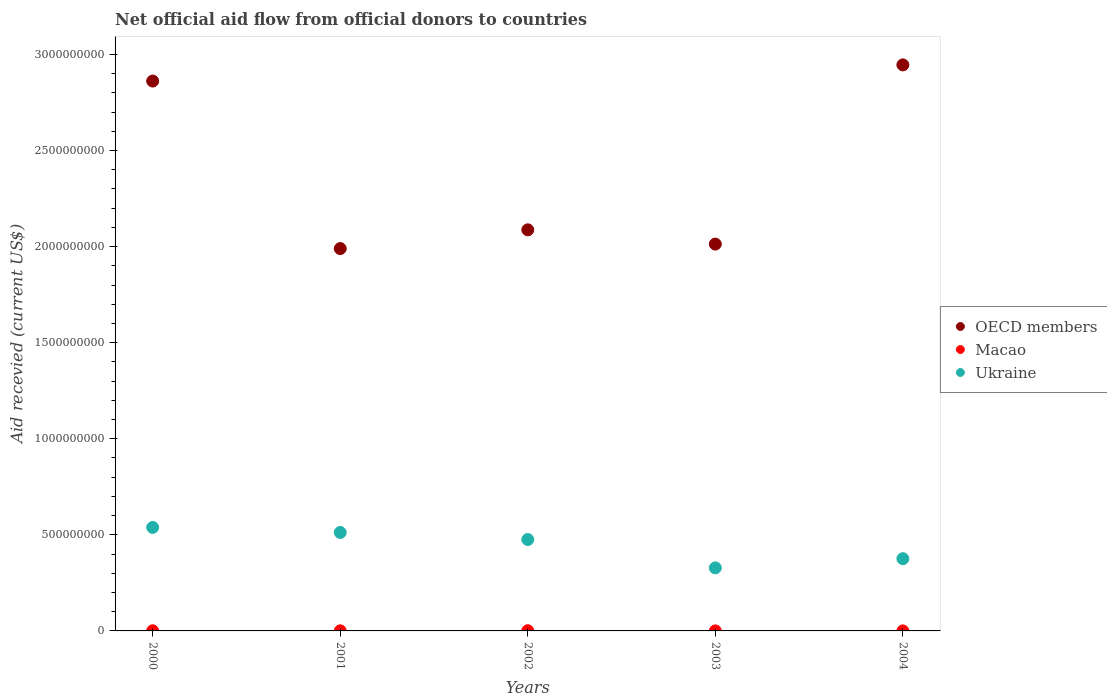Is the number of dotlines equal to the number of legend labels?
Your answer should be compact. Yes. What is the total aid received in OECD members in 2003?
Provide a short and direct response. 2.01e+09. Across all years, what is the maximum total aid received in OECD members?
Give a very brief answer. 2.95e+09. Across all years, what is the minimum total aid received in OECD members?
Offer a very short reply. 1.99e+09. In which year was the total aid received in Ukraine minimum?
Your answer should be very brief. 2003. What is the total total aid received in Macao in the graph?
Make the answer very short. 2.44e+06. What is the difference between the total aid received in OECD members in 2000 and that in 2002?
Ensure brevity in your answer.  7.74e+08. What is the difference between the total aid received in Ukraine in 2003 and the total aid received in OECD members in 2001?
Your answer should be very brief. -1.66e+09. What is the average total aid received in Macao per year?
Your response must be concise. 4.88e+05. In the year 2000, what is the difference between the total aid received in Macao and total aid received in Ukraine?
Provide a succinct answer. -5.38e+08. What is the ratio of the total aid received in Macao in 2001 to that in 2003?
Ensure brevity in your answer.  4.08. Is the total aid received in OECD members in 2000 less than that in 2004?
Offer a terse response. Yes. What is the difference between the highest and the second highest total aid received in Macao?
Your answer should be compact. 3.00e+05. What is the difference between the highest and the lowest total aid received in Ukraine?
Keep it short and to the point. 2.10e+08. Does the total aid received in OECD members monotonically increase over the years?
Your response must be concise. No. Is the total aid received in OECD members strictly less than the total aid received in Macao over the years?
Offer a very short reply. No. How many dotlines are there?
Offer a very short reply. 3. What is the difference between two consecutive major ticks on the Y-axis?
Your response must be concise. 5.00e+08. Are the values on the major ticks of Y-axis written in scientific E-notation?
Provide a short and direct response. No. Where does the legend appear in the graph?
Offer a very short reply. Center right. How are the legend labels stacked?
Offer a very short reply. Vertical. What is the title of the graph?
Provide a short and direct response. Net official aid flow from official donors to countries. What is the label or title of the X-axis?
Your response must be concise. Years. What is the label or title of the Y-axis?
Ensure brevity in your answer.  Aid recevied (current US$). What is the Aid recevied (current US$) in OECD members in 2000?
Provide a succinct answer. 2.86e+09. What is the Aid recevied (current US$) of Macao in 2000?
Give a very brief answer. 6.80e+05. What is the Aid recevied (current US$) in Ukraine in 2000?
Offer a very short reply. 5.39e+08. What is the Aid recevied (current US$) in OECD members in 2001?
Offer a very short reply. 1.99e+09. What is the Aid recevied (current US$) of Macao in 2001?
Your response must be concise. 5.30e+05. What is the Aid recevied (current US$) of Ukraine in 2001?
Offer a very short reply. 5.12e+08. What is the Aid recevied (current US$) in OECD members in 2002?
Provide a short and direct response. 2.09e+09. What is the Aid recevied (current US$) of Macao in 2002?
Your response must be concise. 9.80e+05. What is the Aid recevied (current US$) of Ukraine in 2002?
Your response must be concise. 4.76e+08. What is the Aid recevied (current US$) of OECD members in 2003?
Your answer should be very brief. 2.01e+09. What is the Aid recevied (current US$) in Macao in 2003?
Ensure brevity in your answer.  1.30e+05. What is the Aid recevied (current US$) in Ukraine in 2003?
Your response must be concise. 3.28e+08. What is the Aid recevied (current US$) of OECD members in 2004?
Provide a succinct answer. 2.95e+09. What is the Aid recevied (current US$) of Macao in 2004?
Provide a short and direct response. 1.20e+05. What is the Aid recevied (current US$) of Ukraine in 2004?
Your answer should be very brief. 3.76e+08. Across all years, what is the maximum Aid recevied (current US$) in OECD members?
Provide a short and direct response. 2.95e+09. Across all years, what is the maximum Aid recevied (current US$) in Macao?
Make the answer very short. 9.80e+05. Across all years, what is the maximum Aid recevied (current US$) in Ukraine?
Your answer should be compact. 5.39e+08. Across all years, what is the minimum Aid recevied (current US$) of OECD members?
Provide a succinct answer. 1.99e+09. Across all years, what is the minimum Aid recevied (current US$) of Ukraine?
Ensure brevity in your answer.  3.28e+08. What is the total Aid recevied (current US$) in OECD members in the graph?
Give a very brief answer. 1.19e+1. What is the total Aid recevied (current US$) of Macao in the graph?
Make the answer very short. 2.44e+06. What is the total Aid recevied (current US$) of Ukraine in the graph?
Make the answer very short. 2.23e+09. What is the difference between the Aid recevied (current US$) in OECD members in 2000 and that in 2001?
Offer a very short reply. 8.72e+08. What is the difference between the Aid recevied (current US$) of Ukraine in 2000 and that in 2001?
Ensure brevity in your answer.  2.62e+07. What is the difference between the Aid recevied (current US$) in OECD members in 2000 and that in 2002?
Provide a short and direct response. 7.74e+08. What is the difference between the Aid recevied (current US$) in Ukraine in 2000 and that in 2002?
Your answer should be very brief. 6.32e+07. What is the difference between the Aid recevied (current US$) in OECD members in 2000 and that in 2003?
Offer a very short reply. 8.48e+08. What is the difference between the Aid recevied (current US$) of Ukraine in 2000 and that in 2003?
Give a very brief answer. 2.10e+08. What is the difference between the Aid recevied (current US$) of OECD members in 2000 and that in 2004?
Your answer should be very brief. -8.42e+07. What is the difference between the Aid recevied (current US$) in Macao in 2000 and that in 2004?
Offer a very short reply. 5.60e+05. What is the difference between the Aid recevied (current US$) in Ukraine in 2000 and that in 2004?
Give a very brief answer. 1.63e+08. What is the difference between the Aid recevied (current US$) in OECD members in 2001 and that in 2002?
Provide a short and direct response. -9.76e+07. What is the difference between the Aid recevied (current US$) of Macao in 2001 and that in 2002?
Your answer should be very brief. -4.50e+05. What is the difference between the Aid recevied (current US$) of Ukraine in 2001 and that in 2002?
Make the answer very short. 3.69e+07. What is the difference between the Aid recevied (current US$) of OECD members in 2001 and that in 2003?
Provide a succinct answer. -2.34e+07. What is the difference between the Aid recevied (current US$) in Ukraine in 2001 and that in 2003?
Offer a terse response. 1.84e+08. What is the difference between the Aid recevied (current US$) of OECD members in 2001 and that in 2004?
Your response must be concise. -9.56e+08. What is the difference between the Aid recevied (current US$) of Ukraine in 2001 and that in 2004?
Your response must be concise. 1.36e+08. What is the difference between the Aid recevied (current US$) of OECD members in 2002 and that in 2003?
Your answer should be compact. 7.41e+07. What is the difference between the Aid recevied (current US$) in Macao in 2002 and that in 2003?
Ensure brevity in your answer.  8.50e+05. What is the difference between the Aid recevied (current US$) of Ukraine in 2002 and that in 2003?
Your answer should be very brief. 1.47e+08. What is the difference between the Aid recevied (current US$) in OECD members in 2002 and that in 2004?
Offer a very short reply. -8.58e+08. What is the difference between the Aid recevied (current US$) in Macao in 2002 and that in 2004?
Provide a succinct answer. 8.60e+05. What is the difference between the Aid recevied (current US$) of Ukraine in 2002 and that in 2004?
Provide a short and direct response. 9.96e+07. What is the difference between the Aid recevied (current US$) in OECD members in 2003 and that in 2004?
Make the answer very short. -9.33e+08. What is the difference between the Aid recevied (current US$) of Macao in 2003 and that in 2004?
Give a very brief answer. 10000. What is the difference between the Aid recevied (current US$) of Ukraine in 2003 and that in 2004?
Your answer should be very brief. -4.78e+07. What is the difference between the Aid recevied (current US$) in OECD members in 2000 and the Aid recevied (current US$) in Macao in 2001?
Make the answer very short. 2.86e+09. What is the difference between the Aid recevied (current US$) of OECD members in 2000 and the Aid recevied (current US$) of Ukraine in 2001?
Provide a succinct answer. 2.35e+09. What is the difference between the Aid recevied (current US$) in Macao in 2000 and the Aid recevied (current US$) in Ukraine in 2001?
Make the answer very short. -5.12e+08. What is the difference between the Aid recevied (current US$) in OECD members in 2000 and the Aid recevied (current US$) in Macao in 2002?
Provide a succinct answer. 2.86e+09. What is the difference between the Aid recevied (current US$) in OECD members in 2000 and the Aid recevied (current US$) in Ukraine in 2002?
Your response must be concise. 2.39e+09. What is the difference between the Aid recevied (current US$) of Macao in 2000 and the Aid recevied (current US$) of Ukraine in 2002?
Your response must be concise. -4.75e+08. What is the difference between the Aid recevied (current US$) of OECD members in 2000 and the Aid recevied (current US$) of Macao in 2003?
Provide a short and direct response. 2.86e+09. What is the difference between the Aid recevied (current US$) in OECD members in 2000 and the Aid recevied (current US$) in Ukraine in 2003?
Ensure brevity in your answer.  2.53e+09. What is the difference between the Aid recevied (current US$) of Macao in 2000 and the Aid recevied (current US$) of Ukraine in 2003?
Make the answer very short. -3.28e+08. What is the difference between the Aid recevied (current US$) in OECD members in 2000 and the Aid recevied (current US$) in Macao in 2004?
Provide a short and direct response. 2.86e+09. What is the difference between the Aid recevied (current US$) in OECD members in 2000 and the Aid recevied (current US$) in Ukraine in 2004?
Ensure brevity in your answer.  2.49e+09. What is the difference between the Aid recevied (current US$) of Macao in 2000 and the Aid recevied (current US$) of Ukraine in 2004?
Your answer should be compact. -3.75e+08. What is the difference between the Aid recevied (current US$) in OECD members in 2001 and the Aid recevied (current US$) in Macao in 2002?
Your answer should be very brief. 1.99e+09. What is the difference between the Aid recevied (current US$) of OECD members in 2001 and the Aid recevied (current US$) of Ukraine in 2002?
Offer a very short reply. 1.51e+09. What is the difference between the Aid recevied (current US$) in Macao in 2001 and the Aid recevied (current US$) in Ukraine in 2002?
Offer a terse response. -4.75e+08. What is the difference between the Aid recevied (current US$) of OECD members in 2001 and the Aid recevied (current US$) of Macao in 2003?
Make the answer very short. 1.99e+09. What is the difference between the Aid recevied (current US$) in OECD members in 2001 and the Aid recevied (current US$) in Ukraine in 2003?
Make the answer very short. 1.66e+09. What is the difference between the Aid recevied (current US$) in Macao in 2001 and the Aid recevied (current US$) in Ukraine in 2003?
Provide a succinct answer. -3.28e+08. What is the difference between the Aid recevied (current US$) of OECD members in 2001 and the Aid recevied (current US$) of Macao in 2004?
Provide a short and direct response. 1.99e+09. What is the difference between the Aid recevied (current US$) in OECD members in 2001 and the Aid recevied (current US$) in Ukraine in 2004?
Your answer should be very brief. 1.61e+09. What is the difference between the Aid recevied (current US$) in Macao in 2001 and the Aid recevied (current US$) in Ukraine in 2004?
Ensure brevity in your answer.  -3.75e+08. What is the difference between the Aid recevied (current US$) in OECD members in 2002 and the Aid recevied (current US$) in Macao in 2003?
Your answer should be compact. 2.09e+09. What is the difference between the Aid recevied (current US$) in OECD members in 2002 and the Aid recevied (current US$) in Ukraine in 2003?
Your answer should be very brief. 1.76e+09. What is the difference between the Aid recevied (current US$) in Macao in 2002 and the Aid recevied (current US$) in Ukraine in 2003?
Offer a very short reply. -3.27e+08. What is the difference between the Aid recevied (current US$) of OECD members in 2002 and the Aid recevied (current US$) of Macao in 2004?
Give a very brief answer. 2.09e+09. What is the difference between the Aid recevied (current US$) of OECD members in 2002 and the Aid recevied (current US$) of Ukraine in 2004?
Ensure brevity in your answer.  1.71e+09. What is the difference between the Aid recevied (current US$) in Macao in 2002 and the Aid recevied (current US$) in Ukraine in 2004?
Ensure brevity in your answer.  -3.75e+08. What is the difference between the Aid recevied (current US$) of OECD members in 2003 and the Aid recevied (current US$) of Macao in 2004?
Give a very brief answer. 2.01e+09. What is the difference between the Aid recevied (current US$) of OECD members in 2003 and the Aid recevied (current US$) of Ukraine in 2004?
Your answer should be very brief. 1.64e+09. What is the difference between the Aid recevied (current US$) in Macao in 2003 and the Aid recevied (current US$) in Ukraine in 2004?
Your answer should be very brief. -3.76e+08. What is the average Aid recevied (current US$) in OECD members per year?
Make the answer very short. 2.38e+09. What is the average Aid recevied (current US$) in Macao per year?
Provide a succinct answer. 4.88e+05. What is the average Aid recevied (current US$) of Ukraine per year?
Provide a succinct answer. 4.46e+08. In the year 2000, what is the difference between the Aid recevied (current US$) of OECD members and Aid recevied (current US$) of Macao?
Ensure brevity in your answer.  2.86e+09. In the year 2000, what is the difference between the Aid recevied (current US$) of OECD members and Aid recevied (current US$) of Ukraine?
Offer a very short reply. 2.32e+09. In the year 2000, what is the difference between the Aid recevied (current US$) of Macao and Aid recevied (current US$) of Ukraine?
Your answer should be very brief. -5.38e+08. In the year 2001, what is the difference between the Aid recevied (current US$) of OECD members and Aid recevied (current US$) of Macao?
Provide a short and direct response. 1.99e+09. In the year 2001, what is the difference between the Aid recevied (current US$) in OECD members and Aid recevied (current US$) in Ukraine?
Ensure brevity in your answer.  1.48e+09. In the year 2001, what is the difference between the Aid recevied (current US$) of Macao and Aid recevied (current US$) of Ukraine?
Your response must be concise. -5.12e+08. In the year 2002, what is the difference between the Aid recevied (current US$) of OECD members and Aid recevied (current US$) of Macao?
Provide a short and direct response. 2.09e+09. In the year 2002, what is the difference between the Aid recevied (current US$) in OECD members and Aid recevied (current US$) in Ukraine?
Your response must be concise. 1.61e+09. In the year 2002, what is the difference between the Aid recevied (current US$) in Macao and Aid recevied (current US$) in Ukraine?
Your answer should be very brief. -4.75e+08. In the year 2003, what is the difference between the Aid recevied (current US$) of OECD members and Aid recevied (current US$) of Macao?
Offer a terse response. 2.01e+09. In the year 2003, what is the difference between the Aid recevied (current US$) in OECD members and Aid recevied (current US$) in Ukraine?
Your response must be concise. 1.68e+09. In the year 2003, what is the difference between the Aid recevied (current US$) in Macao and Aid recevied (current US$) in Ukraine?
Give a very brief answer. -3.28e+08. In the year 2004, what is the difference between the Aid recevied (current US$) of OECD members and Aid recevied (current US$) of Macao?
Give a very brief answer. 2.95e+09. In the year 2004, what is the difference between the Aid recevied (current US$) in OECD members and Aid recevied (current US$) in Ukraine?
Your answer should be very brief. 2.57e+09. In the year 2004, what is the difference between the Aid recevied (current US$) in Macao and Aid recevied (current US$) in Ukraine?
Offer a terse response. -3.76e+08. What is the ratio of the Aid recevied (current US$) of OECD members in 2000 to that in 2001?
Ensure brevity in your answer.  1.44. What is the ratio of the Aid recevied (current US$) in Macao in 2000 to that in 2001?
Provide a short and direct response. 1.28. What is the ratio of the Aid recevied (current US$) in Ukraine in 2000 to that in 2001?
Provide a short and direct response. 1.05. What is the ratio of the Aid recevied (current US$) in OECD members in 2000 to that in 2002?
Make the answer very short. 1.37. What is the ratio of the Aid recevied (current US$) of Macao in 2000 to that in 2002?
Offer a very short reply. 0.69. What is the ratio of the Aid recevied (current US$) in Ukraine in 2000 to that in 2002?
Give a very brief answer. 1.13. What is the ratio of the Aid recevied (current US$) of OECD members in 2000 to that in 2003?
Offer a very short reply. 1.42. What is the ratio of the Aid recevied (current US$) of Macao in 2000 to that in 2003?
Ensure brevity in your answer.  5.23. What is the ratio of the Aid recevied (current US$) of Ukraine in 2000 to that in 2003?
Keep it short and to the point. 1.64. What is the ratio of the Aid recevied (current US$) in OECD members in 2000 to that in 2004?
Your response must be concise. 0.97. What is the ratio of the Aid recevied (current US$) of Macao in 2000 to that in 2004?
Provide a short and direct response. 5.67. What is the ratio of the Aid recevied (current US$) of Ukraine in 2000 to that in 2004?
Keep it short and to the point. 1.43. What is the ratio of the Aid recevied (current US$) in OECD members in 2001 to that in 2002?
Make the answer very short. 0.95. What is the ratio of the Aid recevied (current US$) in Macao in 2001 to that in 2002?
Your answer should be very brief. 0.54. What is the ratio of the Aid recevied (current US$) in Ukraine in 2001 to that in 2002?
Keep it short and to the point. 1.08. What is the ratio of the Aid recevied (current US$) in OECD members in 2001 to that in 2003?
Make the answer very short. 0.99. What is the ratio of the Aid recevied (current US$) of Macao in 2001 to that in 2003?
Ensure brevity in your answer.  4.08. What is the ratio of the Aid recevied (current US$) in Ukraine in 2001 to that in 2003?
Your response must be concise. 1.56. What is the ratio of the Aid recevied (current US$) of OECD members in 2001 to that in 2004?
Offer a terse response. 0.68. What is the ratio of the Aid recevied (current US$) of Macao in 2001 to that in 2004?
Offer a terse response. 4.42. What is the ratio of the Aid recevied (current US$) of Ukraine in 2001 to that in 2004?
Your answer should be compact. 1.36. What is the ratio of the Aid recevied (current US$) in OECD members in 2002 to that in 2003?
Your answer should be compact. 1.04. What is the ratio of the Aid recevied (current US$) in Macao in 2002 to that in 2003?
Provide a succinct answer. 7.54. What is the ratio of the Aid recevied (current US$) in Ukraine in 2002 to that in 2003?
Your answer should be compact. 1.45. What is the ratio of the Aid recevied (current US$) in OECD members in 2002 to that in 2004?
Your answer should be very brief. 0.71. What is the ratio of the Aid recevied (current US$) of Macao in 2002 to that in 2004?
Give a very brief answer. 8.17. What is the ratio of the Aid recevied (current US$) in Ukraine in 2002 to that in 2004?
Provide a short and direct response. 1.26. What is the ratio of the Aid recevied (current US$) of OECD members in 2003 to that in 2004?
Provide a succinct answer. 0.68. What is the ratio of the Aid recevied (current US$) in Ukraine in 2003 to that in 2004?
Provide a succinct answer. 0.87. What is the difference between the highest and the second highest Aid recevied (current US$) in OECD members?
Provide a succinct answer. 8.42e+07. What is the difference between the highest and the second highest Aid recevied (current US$) of Ukraine?
Your response must be concise. 2.62e+07. What is the difference between the highest and the lowest Aid recevied (current US$) of OECD members?
Offer a terse response. 9.56e+08. What is the difference between the highest and the lowest Aid recevied (current US$) in Macao?
Your answer should be very brief. 8.60e+05. What is the difference between the highest and the lowest Aid recevied (current US$) of Ukraine?
Ensure brevity in your answer.  2.10e+08. 